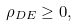<formula> <loc_0><loc_0><loc_500><loc_500>\rho _ { D E } \geq 0 ,</formula> 